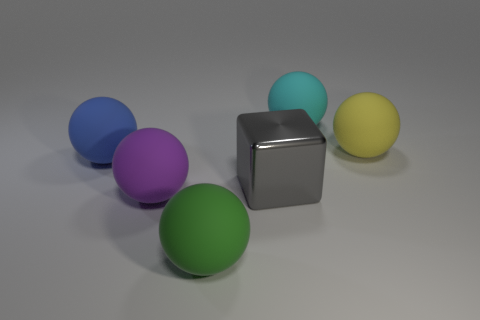Subtract all large blue matte balls. How many balls are left? 4 Add 1 big green matte things. How many objects exist? 7 Subtract all purple spheres. How many spheres are left? 4 Subtract 1 cubes. How many cubes are left? 0 Add 4 large gray things. How many large gray things exist? 5 Subtract 0 red cubes. How many objects are left? 6 Subtract all cubes. How many objects are left? 5 Subtract all yellow blocks. Subtract all brown cylinders. How many blocks are left? 1 Subtract all green cubes. How many yellow balls are left? 1 Subtract all big blue metal blocks. Subtract all gray things. How many objects are left? 5 